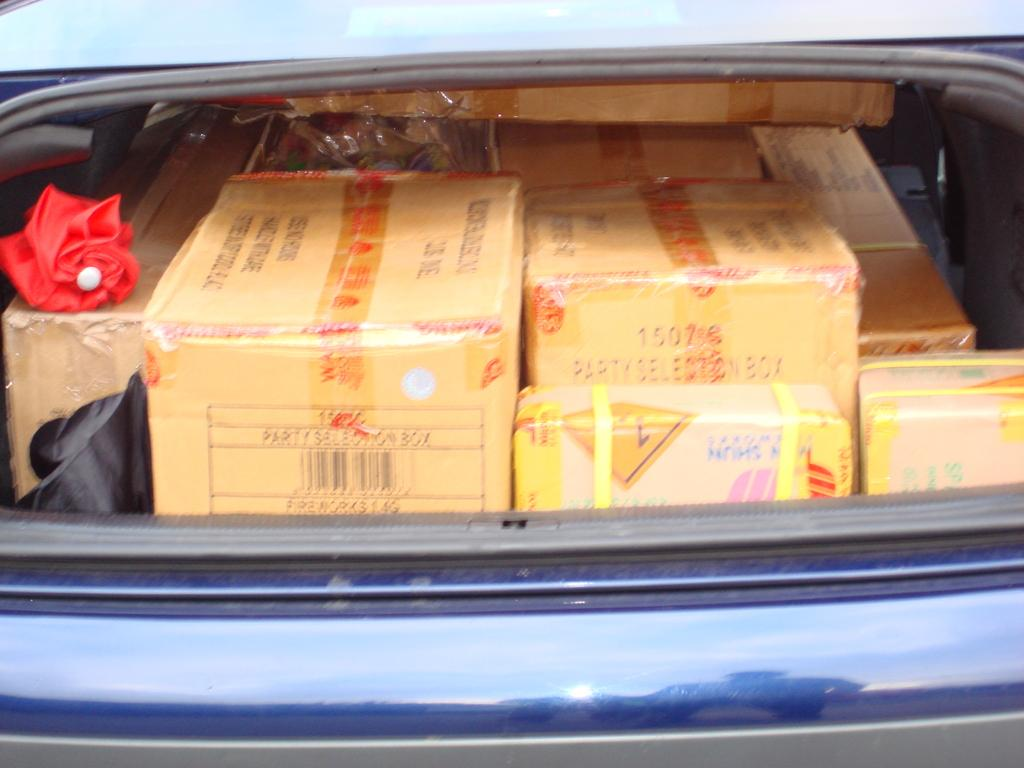What is the main subject of the image? There is a vehicle in the image. What can be found inside the vehicle? There are boxes in the vehicle. Is there any additional object visible in the image? Yes, there is an umbrella in the image. What type of land can be seen in the image? There is no land visible in the image; it only features a vehicle, boxes, and an umbrella. Is there a camp set up in the image? There is no camp present in the image. 